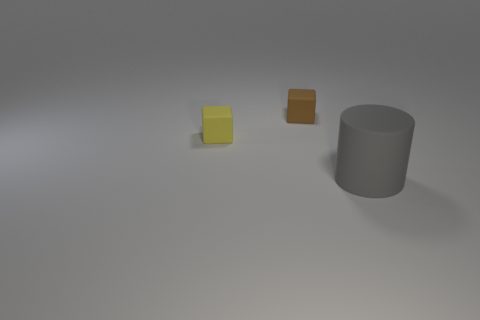What is the size of the other object that is the same shape as the brown matte thing?
Provide a short and direct response. Small. How many brown objects are the same shape as the small yellow matte thing?
Your response must be concise. 1. What number of big yellow metallic balls are there?
Your answer should be very brief. 0. What size is the object that is in front of the brown matte thing and to the right of the yellow rubber object?
Offer a very short reply. Large. There is a brown object that is the same size as the yellow rubber block; what is its shape?
Give a very brief answer. Cube. There is a tiny cube in front of the tiny brown matte cube; is there a small rubber object on the right side of it?
Provide a short and direct response. Yes. There is another small rubber thing that is the same shape as the tiny brown rubber thing; what is its color?
Offer a terse response. Yellow. Do the small thing that is left of the brown rubber block and the large object have the same color?
Give a very brief answer. No. What number of objects are either small things to the right of the yellow cube or yellow matte things?
Your answer should be compact. 2. The cube behind the tiny matte cube that is in front of the small cube that is on the right side of the tiny yellow matte block is made of what material?
Provide a succinct answer. Rubber. 